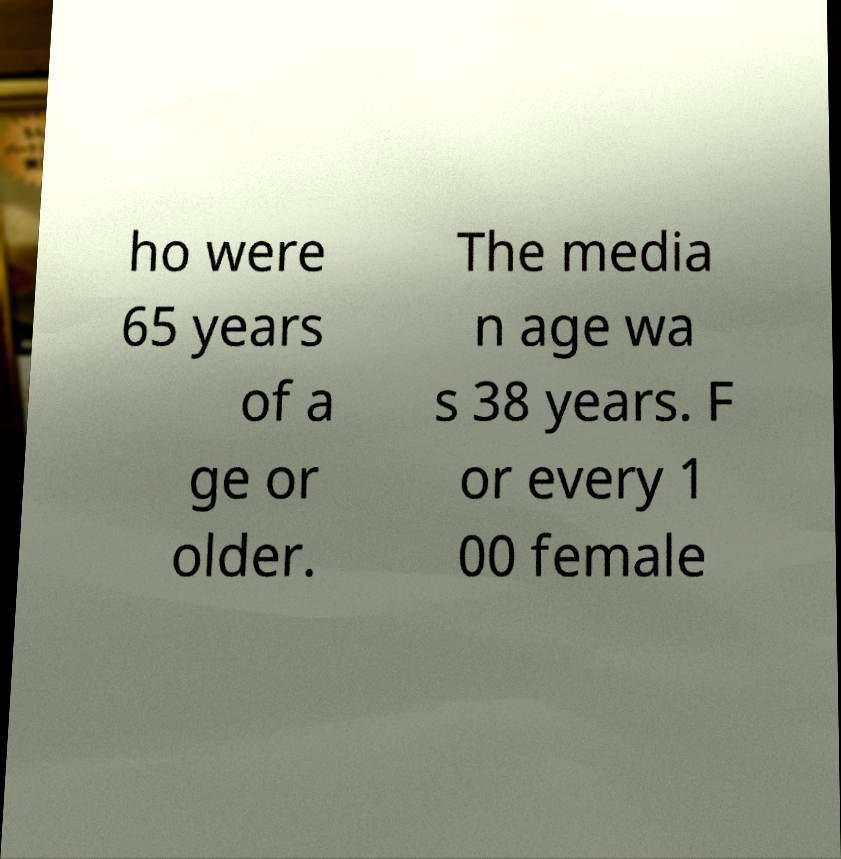What messages or text are displayed in this image? I need them in a readable, typed format. ho were 65 years of a ge or older. The media n age wa s 38 years. F or every 1 00 female 